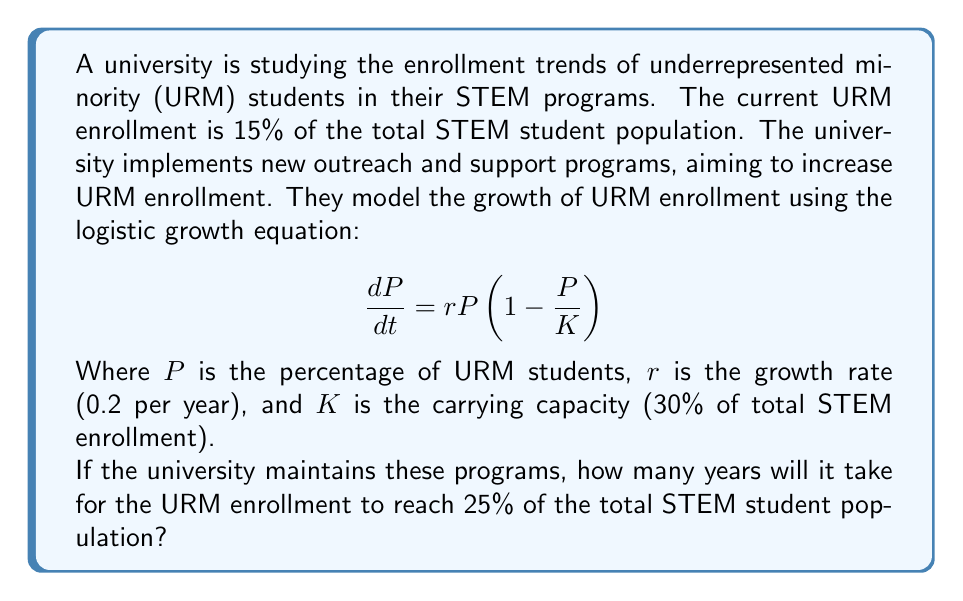Can you solve this math problem? To solve this problem, we need to use the logistic growth equation and integrate it to find the time required. Let's approach this step-by-step:

1) The logistic growth equation is given by:
   $$\frac{dP}{dt} = rP(1-\frac{P}{K})$$

2) We need to integrate this equation. The integrated form is:
   $$P(t) = \frac{K}{1 + (\frac{K}{P_0} - 1)e^{-rt}}$$

   Where $P_0$ is the initial population percentage.

3) We know the following values:
   $P_0 = 15\%$ (initial URM enrollment)
   $K = 30\%$ (carrying capacity)
   $r = 0.2$ per year (growth rate)
   $P(t) = 25\%$ (target URM enrollment)

4) Let's substitute these values into the equation:
   $$0.25 = \frac{0.3}{1 + (\frac{0.3}{0.15} - 1)e^{-0.2t}}$$

5) Now, let's solve for $t$:
   $$1 + (\frac{0.3}{0.15} - 1)e^{-0.2t} = \frac{0.3}{0.25}$$
   $$(\frac{0.3}{0.15} - 1)e^{-0.2t} = \frac{0.3}{0.25} - 1$$
   $$e^{-0.2t} = \frac{\frac{0.3}{0.25} - 1}{\frac{0.3}{0.15} - 1}$$
   $$-0.2t = \ln(\frac{\frac{0.3}{0.25} - 1}{\frac{0.3}{0.15} - 1})$$
   $$t = -\frac{1}{0.2}\ln(\frac{\frac{0.3}{0.25} - 1}{\frac{0.3}{0.15} - 1})$$

6) Calculating this value:
   $$t \approx 7.79 \text{ years}$$

Therefore, it will take approximately 7.79 years for the URM enrollment to reach 25% of the total STEM student population.
Answer: 7.79 years 